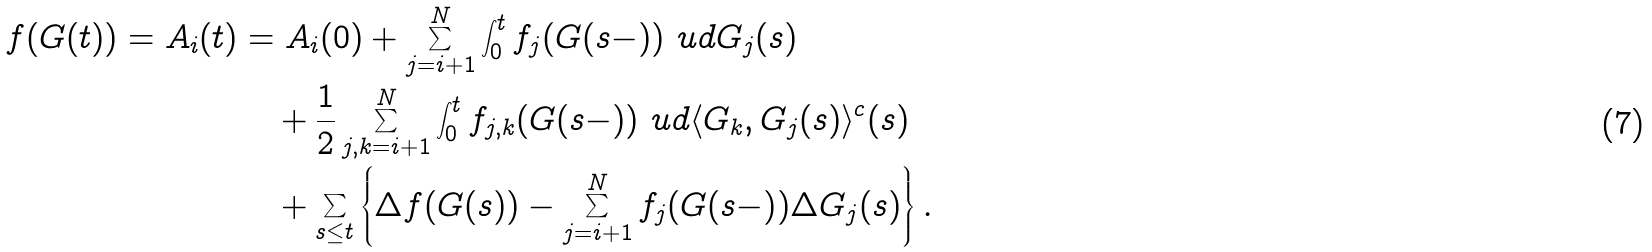Convert formula to latex. <formula><loc_0><loc_0><loc_500><loc_500>f ( G ( t ) ) = A _ { i } ( t ) & = A _ { i } ( 0 ) + \sum _ { j = i + 1 } ^ { N } \int _ { 0 } ^ { t } f _ { j } ( G ( s - ) ) \ u d G _ { j } ( s ) \\ & \quad + \frac { 1 } { 2 } \sum _ { j , k = i + 1 } ^ { N } \int _ { 0 } ^ { t } f _ { j , k } ( G ( s - ) ) \ u d \langle G _ { k } , G _ { j } ( s ) \rangle ^ { c } ( s ) \\ & \quad + \sum _ { s \leq t } \left \{ \Delta f ( G ( s ) ) - \sum _ { j = i + 1 } ^ { N } f _ { j } ( G ( s - ) ) \Delta G _ { j } ( s ) \right \} .</formula> 